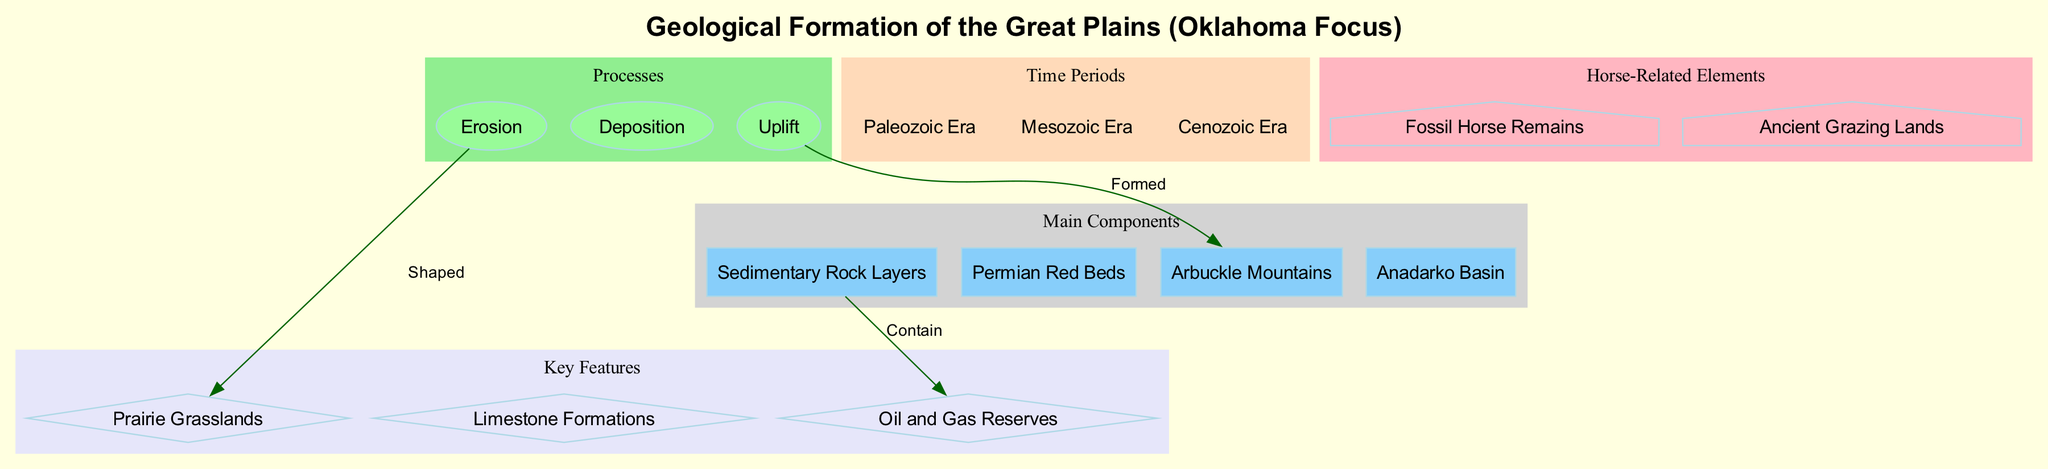What are the main components of the geological formation? The diagram lists four main components: Sedimentary Rock Layers, Permian Red Beds, Arbuckle Mountains, and Anadarko Basin.
Answer: Sedimentary Rock Layers, Permian Red Beds, Arbuckle Mountains, Anadarko Basin What process is described as having shaped the prairie grasslands? The diagram shows a connection labeled "Shaped" from Erosion to Prairie Grasslands, indicating that Erosion is the process that shaped them.
Answer: Erosion How many time periods are identified in the diagram? The diagram mentions three distinct time periods: Paleozoic Era, Mesozoic Era, and Cenozoic Era, which can be counted to answer the question.
Answer: 3 Which key feature is contained within the sedimentary rock layers? According to the diagram's connection labeled "Contain," the Oil and Gas Reserves are contained within the Sedimentary Rock Layers.
Answer: Oil and Gas Reserves What geological feature was formed by uplift? The diagram states that the Arbuckle Mountains were formed by the process of Uplift, which establishes the relationship directly.
Answer: Arbuckle Mountains How many horse-related elements are shown in the diagram? The diagram lists two horse-related elements: Fossil Horse Remains and Ancient Grazing Lands, which can be counted to answer the question.
Answer: 2 Which geologic process contributes to the formation of the Arbuckle Mountains? The Uplift process is indicated in the diagram to have formed the Arbuckle Mountains, as shown in the labeled connection.
Answer: Uplift What type of rock layers are featured in the geological formation? The diagram specifies that Sedimentary Rock Layers are a primary component, directly answering the question about the type.
Answer: Sedimentary Rock Layers What shaped the Prairie Grasslands according to the diagram? The connection labeled "Shaped" in the diagram indicates that the Erosion process is what shaped the Prairie Grasslands.
Answer: Erosion 